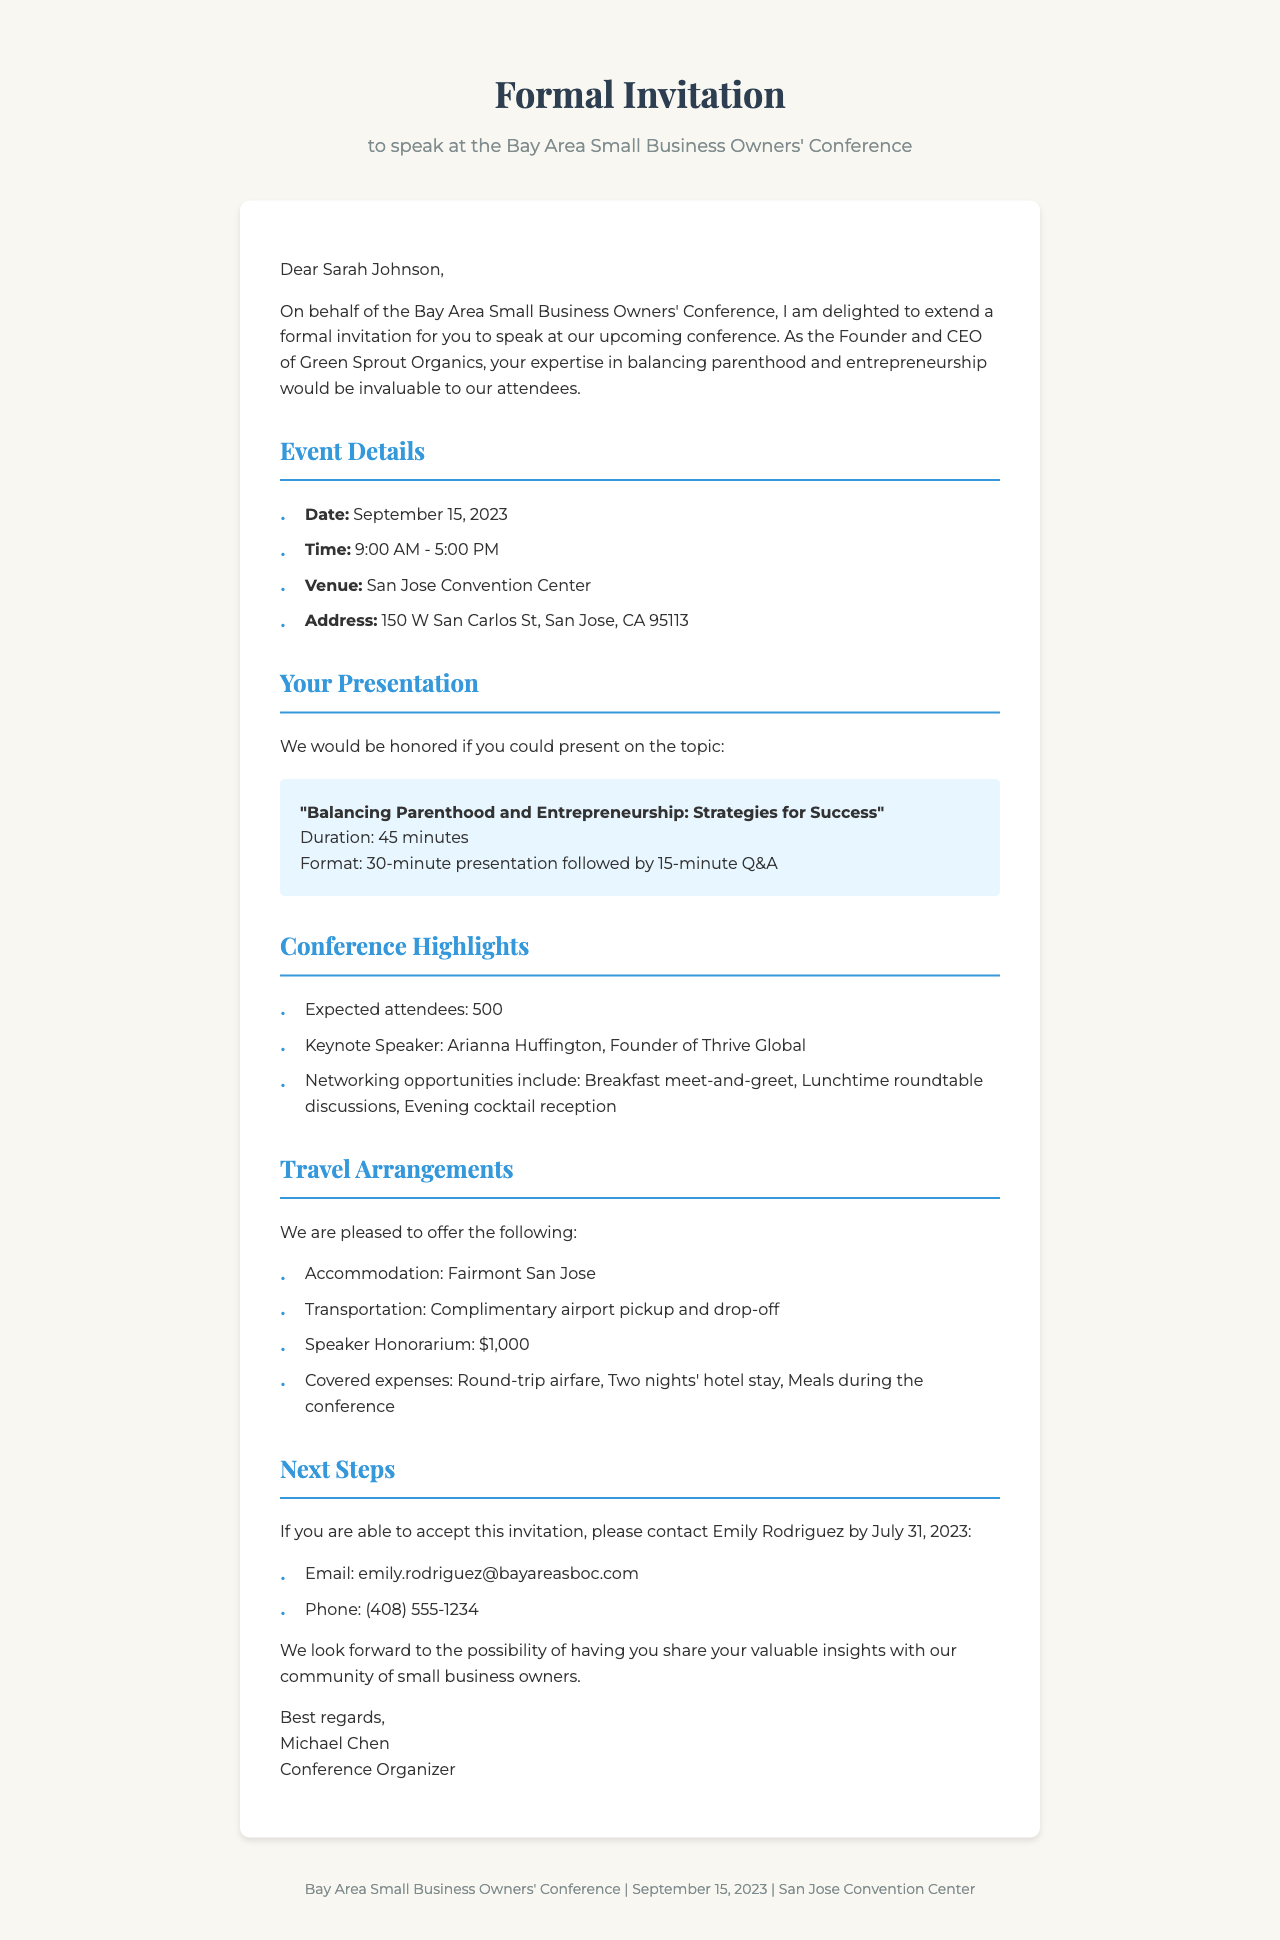What is the name of the conference? The conference is referred to as the Bay Area Small Business Owners' Conference in the document.
Answer: Bay Area Small Business Owners' Conference Who is the invited speaker? The invited speaker is identified in the letter as Sarah Johnson.
Answer: Sarah Johnson What is the date of the event? The document states that the event will take place on September 15, 2023.
Answer: September 15, 2023 What is the duration of the presentation? The presentation duration is provided as 45 minutes in the invitation.
Answer: 45 minutes What is the speaker honorarium? The speaker honorarium is explicitly mentioned as $1,000 in the financial considerations section.
Answer: $1,000 How many expected attendees are there? The expected number of attendees is mentioned as 500 in the conference highlights.
Answer: 500 What travel arrangements are provided? The travel arrangements include accommodation at Fairmont San Jose and complimentary airport pickup and drop-off.
Answer: Fairmont San Jose What is the topic of the presentation? The topic of the presentation is outlined as "Balancing Parenthood and Entrepreneurship: Strategies for Success."
Answer: Balancing Parenthood and Entrepreneurship: Strategies for Success What is a potential talking point for the speaker? One potential talking point mentioned in the document is time management techniques for busy parent entrepreneurs.
Answer: Time management techniques for busy parent entrepreneurs 